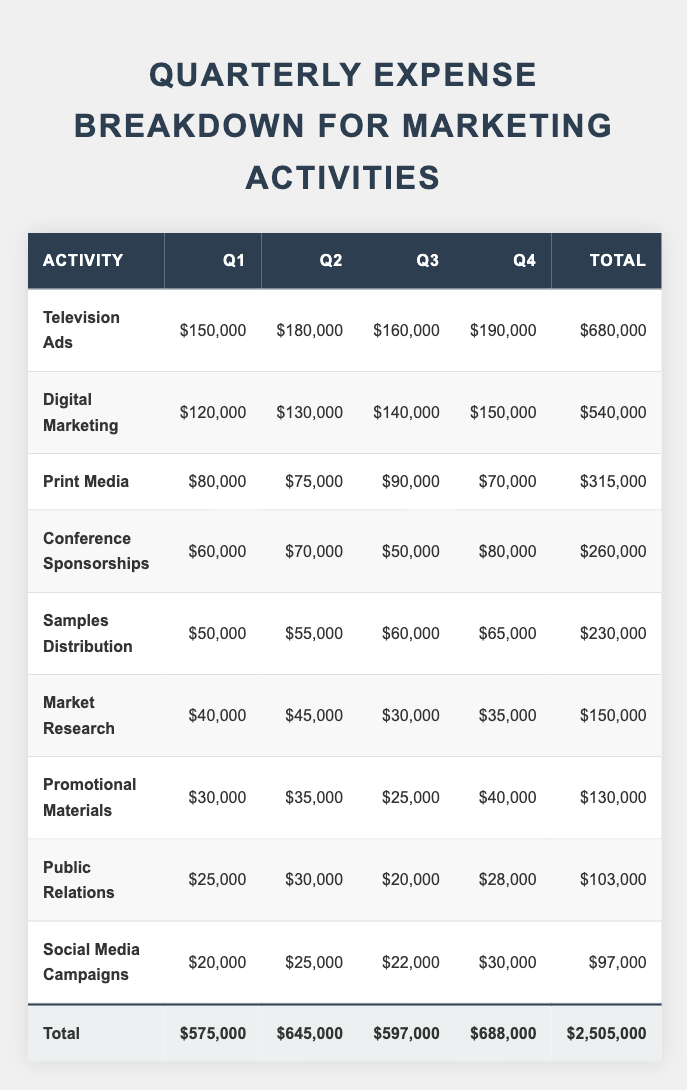What is the total expense for Television Ads in Q3? According to the table, the expense for Television Ads in Q3 is listed as $160,000.
Answer: $160,000 What is the total amount spent on Digital Marketing across all quarters? The table shows the following expenses for Digital Marketing: Q1: $120,000, Q2: $130,000, Q3: $140,000, and Q4: $150,000. Adding these together: 120000 + 130000 + 140000 + 150000 = 540000.
Answer: $540,000 Is the expense for Print Media higher in Q1 than in Q4? The expense for Print Media in Q1 is $80,000, while in Q4 it is $70,000. Since $80,000 is greater than $70,000, the statement is true.
Answer: Yes Which quarter had the highest total expense for Marketing Activities? The total expenses for each quarter are: Q1: $575,000, Q2: $645,000, Q3: $597,000, and Q4: $688,000. The highest total is in Q4 with $688,000.
Answer: Q4 What is the average expense for Conference Sponsorships across the four quarters? Add the expenses for Conference Sponsorships: Q1: $60,000, Q2: $70,000, Q3: $50,000, and Q4: $80,000 to get a total of $260,000. Divide by 4 (the number of quarters): 260000 / 4 = $65,000.
Answer: $65,000 How much more was spent on Samples Distribution in Q4 compared to Q1? The expense for Samples Distribution in Q4 is $65,000 and in Q1 is $50,000. The difference is $65,000 - $50,000 = $15,000.
Answer: $15,000 Which marketing activity had the least total expense over the year? The total expenses for each activity can be summed based on data: Public Relations: $103,000, Social Media Campaigns: $97,000, and Promotional Materials: $130,000. The least is Social Media Campaigns at $97,000.
Answer: Social Media Campaigns What was the total increase in expense from Q1 to Q2 across all activities? The total expenses for Q1 is $575,000 and for Q2 is $645,000. The increase is $645,000 - $575,000 = $70,000.
Answer: $70,000 What is the total expenditure for Market Research in Q3 and Q4 combined? The expense for Market Research in Q3 is $30,000 and in Q4 is $35,000. Adding these gives $30,000 + $35,000 = $65,000.
Answer: $65,000 Which activity accounted for the highest total expense over the four quarters? The total expenses for each activity are: Television Ads: $680,000, Digital Marketing: $540,000. The highest is Television Ads, which totals $680,000.
Answer: Television Ads 